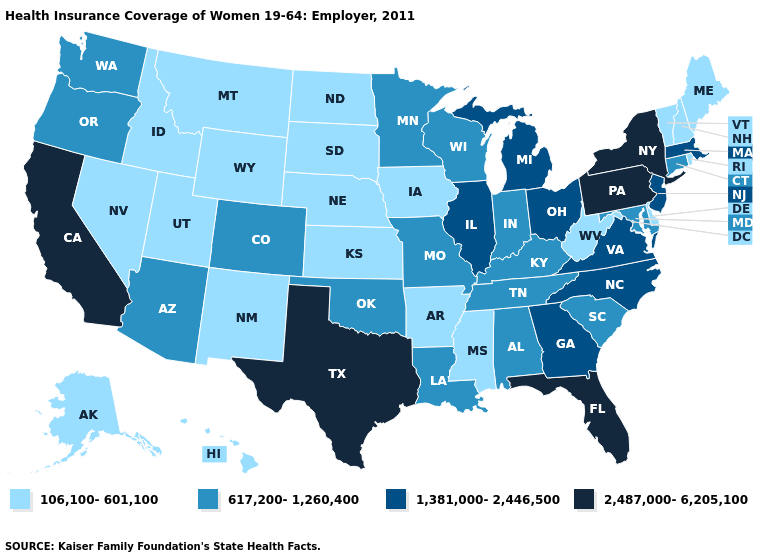What is the value of Delaware?
Quick response, please. 106,100-601,100. What is the value of Michigan?
Keep it brief. 1,381,000-2,446,500. What is the value of Tennessee?
Quick response, please. 617,200-1,260,400. What is the value of Georgia?
Concise answer only. 1,381,000-2,446,500. Does Nebraska have the lowest value in the USA?
Give a very brief answer. Yes. Does the map have missing data?
Concise answer only. No. Does Idaho have the highest value in the USA?
Keep it brief. No. Name the states that have a value in the range 617,200-1,260,400?
Keep it brief. Alabama, Arizona, Colorado, Connecticut, Indiana, Kentucky, Louisiana, Maryland, Minnesota, Missouri, Oklahoma, Oregon, South Carolina, Tennessee, Washington, Wisconsin. Does Iowa have the lowest value in the USA?
Quick response, please. Yes. What is the value of New Jersey?
Write a very short answer. 1,381,000-2,446,500. Does the map have missing data?
Short answer required. No. What is the value of South Dakota?
Give a very brief answer. 106,100-601,100. What is the value of Oklahoma?
Be succinct. 617,200-1,260,400. What is the value of Nevada?
Short answer required. 106,100-601,100. How many symbols are there in the legend?
Be succinct. 4. 